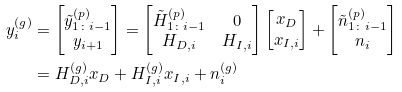<formula> <loc_0><loc_0><loc_500><loc_500>y _ { i } ^ { ( g ) } & = \begin{bmatrix} \tilde { y } _ { 1 \colon i - 1 } ^ { ( p ) } \\ y _ { i + 1 } \end{bmatrix} = \begin{bmatrix} \tilde { H } _ { 1 \colon i - 1 } ^ { ( p ) } & 0 \\ H _ { D , i } & H _ { I , i } \end{bmatrix} \begin{bmatrix} x _ { D } \\ x _ { I , { i } } \end{bmatrix} + \begin{bmatrix} \tilde { n } _ { 1 \colon i - 1 } ^ { ( p ) } \\ n _ { i } \end{bmatrix} \\ & = H _ { D , i } ^ { ( g ) } x _ { D } + H _ { I , i } ^ { ( g ) } x _ { I , i } + n _ { i } ^ { ( g ) }</formula> 